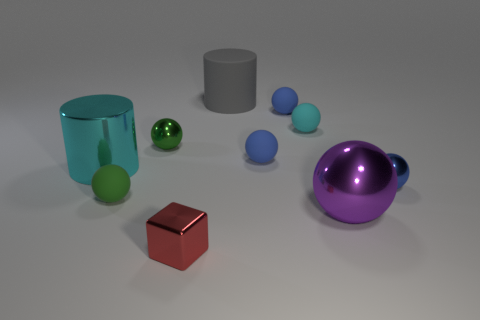Can you describe the lighting setup that might have been used to achieve such clear and reflective surfaces in the image? The lighting in the image appears to be strategically setup to enhance the reflective qualities of the objects. There are likely multiple light sources or a soft box used, aimed at different angles to avoid unwanted shadows and to evenly illuminate each object, thereby bringing out the reflections on the metallic surfaces effectively. 